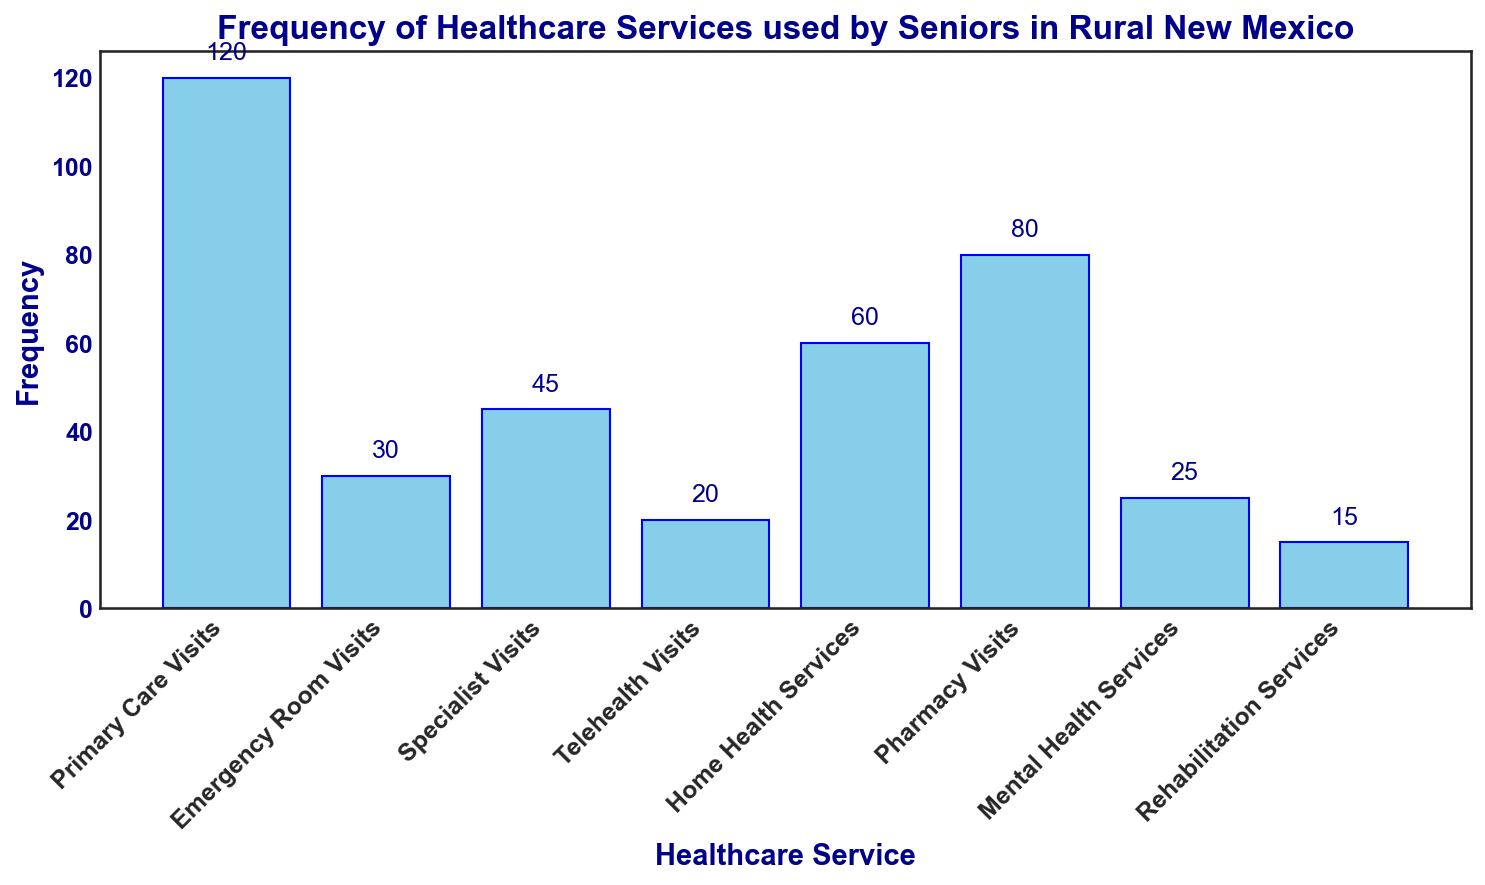Which healthcare service had the highest frequency of use by seniors in rural New Mexico? The bar representing Primary Care Visits is the tallest, indicating that it had the highest frequency of use.
Answer: Primary Care Visits Which healthcare service had the lowest frequency of use by seniors in rural New Mexico? The bar representing Rehabilitation Services is the shortest, indicating that it had the lowest frequency of use.
Answer: Rehabilitation Services How many more Pharmacy Visits were there compared to Telehealth Visits? The bar for Pharmacy Visits reaches up to 80, while the bar for Telehealth Visits reaches up to 20. The difference is 80 - 20 = 60.
Answer: 60 What is the total frequency of Emergency Room Visits and Home Health Services combined? The bar for Emergency Room Visits reaches 30, and the bar for Home Health Services reaches 60. Combined frequency is 30 + 60 = 90.
Answer: 90 What is the average frequency of Primary Care Visits, Specialist Visits, and Home Health Services? The frequencies are 120 for Primary Care Visits, 45 for Specialist Visits, and 60 for Home Health Services. Average is (120 + 45 + 60) / 3 = 75.
Answer: 75 How many fewer Telehealth Visits were there compared to Home Health Services? The bar for Telehealth Visits reaches 20, while the bar for Home Health Services reaches 60. The difference is 60 - 20 = 40.
Answer: 40 Which two services have a combined frequency greater than that of Primary Care Visits? Home Health Services and Pharmacy Visits have frequencies of 60 and 80 respectively. Combined, they are 60 + 80 = 140, which is greater than the 120 of Primary Care Visits.
Answer: Home Health Services and Pharmacy Visits Are there more Specialist Visits or Mental Health Services? The bar for Specialist Visits is taller, reaching 45, compared to the bar for Mental Health Services, which reaches 25.
Answer: Specialist Visits What's the total frequency of all visualized healthcare services? Summing the frequencies: 120 (Primary Care Visits) + 30 (Emergency Room Visits) + 45 (Specialist Visits) + 20 (Telehealth Visits) + 60 (Home Health Services) + 80 (Pharmacy Visits) + 25 (Mental Health Services) + 15 (Rehabilitation Services) = 395.
Answer: 395 How many times more frequent were Primary Care Visits than Rehabilitation Services? Primary Care Visits have a frequency of 120, and Rehabilitation Services have 15. The ratio is 120 / 15 = 8.
Answer: 8 